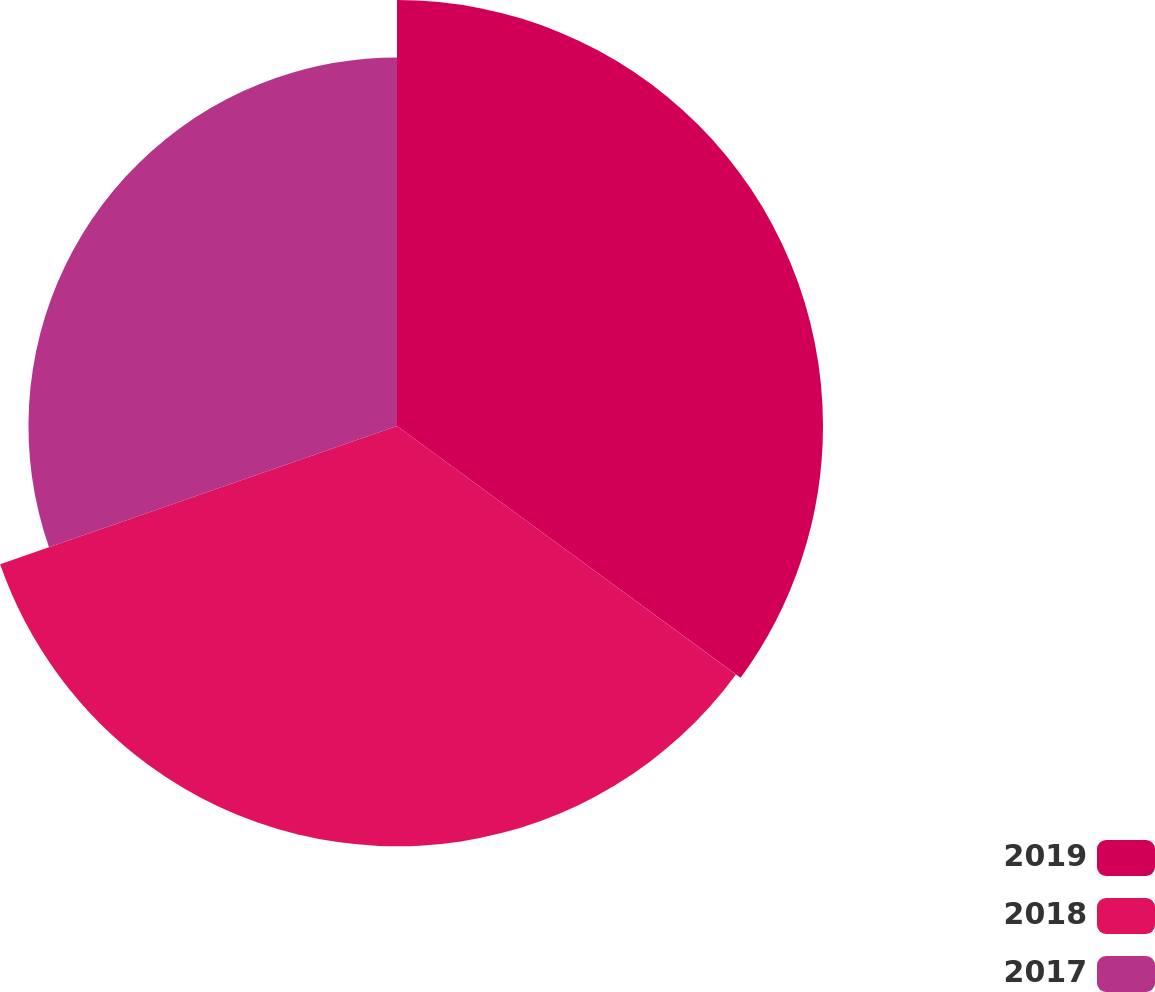Convert chart. <chart><loc_0><loc_0><loc_500><loc_500><pie_chart><fcel>2019<fcel>2018<fcel>2017<nl><fcel>35.07%<fcel>34.6%<fcel>30.34%<nl></chart> 